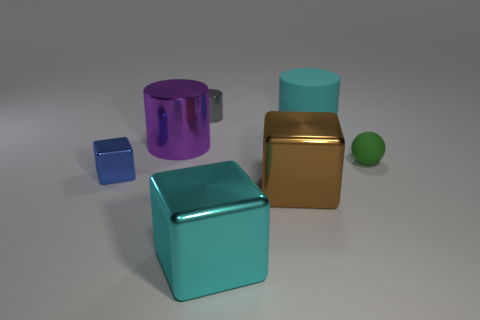There is a metallic thing that is both right of the purple shiny thing and behind the green matte thing; what size is it?
Keep it short and to the point. Small. What is the color of the large cylinder that is the same material as the blue cube?
Your response must be concise. Purple. What number of tiny blue cubes have the same material as the purple thing?
Give a very brief answer. 1. Are there the same number of purple shiny cylinders that are behind the small rubber ball and brown metallic objects that are in front of the big purple object?
Keep it short and to the point. Yes. Do the tiny gray object and the big purple thing that is in front of the big cyan cylinder have the same shape?
Offer a very short reply. Yes. There is another object that is the same color as the big matte thing; what material is it?
Provide a short and direct response. Metal. Is there any other thing that is the same shape as the green object?
Keep it short and to the point. No. Do the green thing and the big cyan object that is behind the tiny blue metal thing have the same material?
Keep it short and to the point. Yes. What color is the cube that is left of the large cylinder in front of the cyan thing that is behind the tiny rubber thing?
Ensure brevity in your answer.  Blue. Do the large rubber object and the large shiny block that is left of the brown metal object have the same color?
Provide a short and direct response. Yes. 